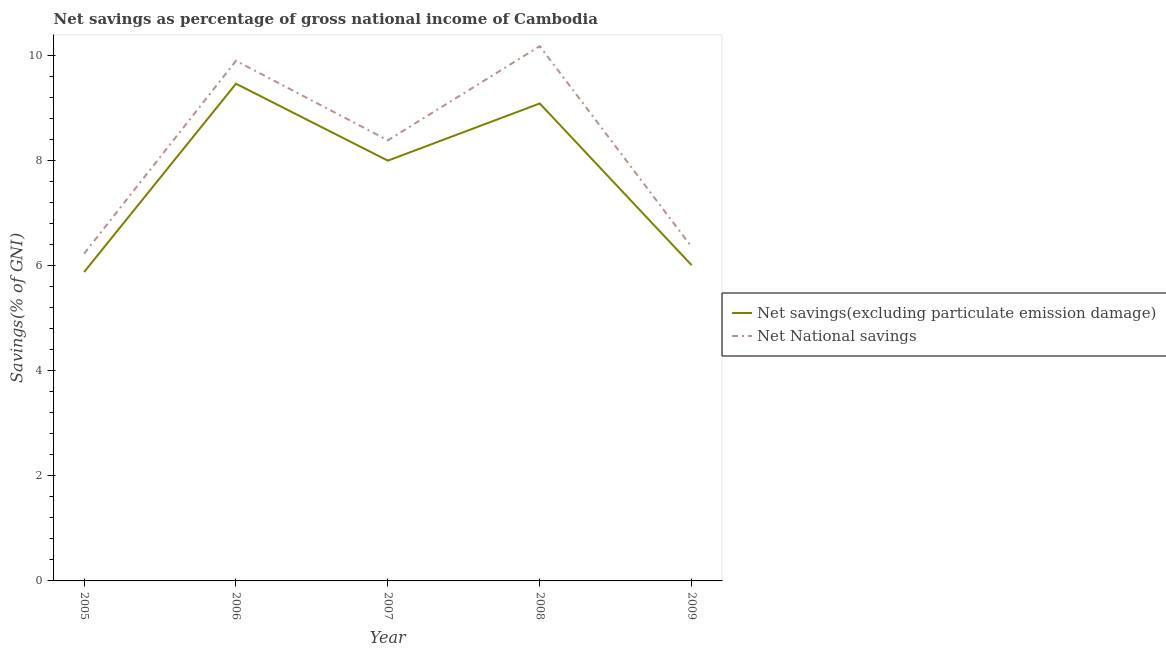How many different coloured lines are there?
Your answer should be compact. 2. What is the net national savings in 2006?
Your response must be concise. 9.9. Across all years, what is the maximum net savings(excluding particulate emission damage)?
Your answer should be very brief. 9.46. Across all years, what is the minimum net national savings?
Provide a short and direct response. 6.23. In which year was the net savings(excluding particulate emission damage) maximum?
Make the answer very short. 2006. What is the total net savings(excluding particulate emission damage) in the graph?
Ensure brevity in your answer.  38.44. What is the difference between the net savings(excluding particulate emission damage) in 2006 and that in 2009?
Your response must be concise. 3.45. What is the difference between the net savings(excluding particulate emission damage) in 2005 and the net national savings in 2006?
Ensure brevity in your answer.  -4.02. What is the average net savings(excluding particulate emission damage) per year?
Offer a very short reply. 7.69. In the year 2005, what is the difference between the net savings(excluding particulate emission damage) and net national savings?
Your response must be concise. -0.35. In how many years, is the net savings(excluding particulate emission damage) greater than 2 %?
Make the answer very short. 5. What is the ratio of the net savings(excluding particulate emission damage) in 2006 to that in 2008?
Your response must be concise. 1.04. Is the net national savings in 2006 less than that in 2007?
Your answer should be compact. No. What is the difference between the highest and the second highest net savings(excluding particulate emission damage)?
Provide a short and direct response. 0.38. What is the difference between the highest and the lowest net savings(excluding particulate emission damage)?
Keep it short and to the point. 3.58. In how many years, is the net national savings greater than the average net national savings taken over all years?
Provide a succinct answer. 3. Is the sum of the net savings(excluding particulate emission damage) in 2007 and 2008 greater than the maximum net national savings across all years?
Give a very brief answer. Yes. Does the net savings(excluding particulate emission damage) monotonically increase over the years?
Make the answer very short. No. Is the net savings(excluding particulate emission damage) strictly greater than the net national savings over the years?
Make the answer very short. No. How many years are there in the graph?
Offer a terse response. 5. Are the values on the major ticks of Y-axis written in scientific E-notation?
Ensure brevity in your answer.  No. How are the legend labels stacked?
Provide a short and direct response. Vertical. What is the title of the graph?
Offer a very short reply. Net savings as percentage of gross national income of Cambodia. What is the label or title of the Y-axis?
Give a very brief answer. Savings(% of GNI). What is the Savings(% of GNI) of Net savings(excluding particulate emission damage) in 2005?
Provide a succinct answer. 5.88. What is the Savings(% of GNI) of Net National savings in 2005?
Offer a very short reply. 6.23. What is the Savings(% of GNI) in Net savings(excluding particulate emission damage) in 2006?
Make the answer very short. 9.46. What is the Savings(% of GNI) in Net National savings in 2006?
Ensure brevity in your answer.  9.9. What is the Savings(% of GNI) of Net savings(excluding particulate emission damage) in 2007?
Give a very brief answer. 8. What is the Savings(% of GNI) in Net National savings in 2007?
Offer a very short reply. 8.39. What is the Savings(% of GNI) of Net savings(excluding particulate emission damage) in 2008?
Make the answer very short. 9.09. What is the Savings(% of GNI) in Net National savings in 2008?
Keep it short and to the point. 10.18. What is the Savings(% of GNI) in Net savings(excluding particulate emission damage) in 2009?
Make the answer very short. 6.01. What is the Savings(% of GNI) of Net National savings in 2009?
Keep it short and to the point. 6.36. Across all years, what is the maximum Savings(% of GNI) in Net savings(excluding particulate emission damage)?
Provide a succinct answer. 9.46. Across all years, what is the maximum Savings(% of GNI) in Net National savings?
Keep it short and to the point. 10.18. Across all years, what is the minimum Savings(% of GNI) of Net savings(excluding particulate emission damage)?
Your answer should be compact. 5.88. Across all years, what is the minimum Savings(% of GNI) of Net National savings?
Keep it short and to the point. 6.23. What is the total Savings(% of GNI) in Net savings(excluding particulate emission damage) in the graph?
Provide a succinct answer. 38.44. What is the total Savings(% of GNI) in Net National savings in the graph?
Your answer should be very brief. 41.05. What is the difference between the Savings(% of GNI) of Net savings(excluding particulate emission damage) in 2005 and that in 2006?
Your response must be concise. -3.58. What is the difference between the Savings(% of GNI) of Net National savings in 2005 and that in 2006?
Provide a short and direct response. -3.67. What is the difference between the Savings(% of GNI) of Net savings(excluding particulate emission damage) in 2005 and that in 2007?
Provide a short and direct response. -2.12. What is the difference between the Savings(% of GNI) of Net National savings in 2005 and that in 2007?
Your answer should be very brief. -2.16. What is the difference between the Savings(% of GNI) in Net savings(excluding particulate emission damage) in 2005 and that in 2008?
Your response must be concise. -3.21. What is the difference between the Savings(% of GNI) of Net National savings in 2005 and that in 2008?
Your answer should be very brief. -3.95. What is the difference between the Savings(% of GNI) of Net savings(excluding particulate emission damage) in 2005 and that in 2009?
Provide a succinct answer. -0.13. What is the difference between the Savings(% of GNI) in Net National savings in 2005 and that in 2009?
Offer a very short reply. -0.13. What is the difference between the Savings(% of GNI) of Net savings(excluding particulate emission damage) in 2006 and that in 2007?
Offer a terse response. 1.46. What is the difference between the Savings(% of GNI) in Net National savings in 2006 and that in 2007?
Your answer should be compact. 1.51. What is the difference between the Savings(% of GNI) in Net savings(excluding particulate emission damage) in 2006 and that in 2008?
Offer a terse response. 0.38. What is the difference between the Savings(% of GNI) in Net National savings in 2006 and that in 2008?
Make the answer very short. -0.28. What is the difference between the Savings(% of GNI) of Net savings(excluding particulate emission damage) in 2006 and that in 2009?
Your response must be concise. 3.45. What is the difference between the Savings(% of GNI) in Net National savings in 2006 and that in 2009?
Keep it short and to the point. 3.54. What is the difference between the Savings(% of GNI) of Net savings(excluding particulate emission damage) in 2007 and that in 2008?
Your answer should be very brief. -1.09. What is the difference between the Savings(% of GNI) in Net National savings in 2007 and that in 2008?
Make the answer very short. -1.79. What is the difference between the Savings(% of GNI) of Net savings(excluding particulate emission damage) in 2007 and that in 2009?
Make the answer very short. 1.99. What is the difference between the Savings(% of GNI) of Net National savings in 2007 and that in 2009?
Your response must be concise. 2.03. What is the difference between the Savings(% of GNI) of Net savings(excluding particulate emission damage) in 2008 and that in 2009?
Ensure brevity in your answer.  3.08. What is the difference between the Savings(% of GNI) of Net National savings in 2008 and that in 2009?
Your response must be concise. 3.82. What is the difference between the Savings(% of GNI) of Net savings(excluding particulate emission damage) in 2005 and the Savings(% of GNI) of Net National savings in 2006?
Keep it short and to the point. -4.02. What is the difference between the Savings(% of GNI) in Net savings(excluding particulate emission damage) in 2005 and the Savings(% of GNI) in Net National savings in 2007?
Offer a terse response. -2.51. What is the difference between the Savings(% of GNI) in Net savings(excluding particulate emission damage) in 2005 and the Savings(% of GNI) in Net National savings in 2008?
Your answer should be very brief. -4.3. What is the difference between the Savings(% of GNI) in Net savings(excluding particulate emission damage) in 2005 and the Savings(% of GNI) in Net National savings in 2009?
Your response must be concise. -0.48. What is the difference between the Savings(% of GNI) of Net savings(excluding particulate emission damage) in 2006 and the Savings(% of GNI) of Net National savings in 2007?
Make the answer very short. 1.08. What is the difference between the Savings(% of GNI) of Net savings(excluding particulate emission damage) in 2006 and the Savings(% of GNI) of Net National savings in 2008?
Your answer should be very brief. -0.72. What is the difference between the Savings(% of GNI) of Net savings(excluding particulate emission damage) in 2006 and the Savings(% of GNI) of Net National savings in 2009?
Make the answer very short. 3.11. What is the difference between the Savings(% of GNI) in Net savings(excluding particulate emission damage) in 2007 and the Savings(% of GNI) in Net National savings in 2008?
Ensure brevity in your answer.  -2.18. What is the difference between the Savings(% of GNI) in Net savings(excluding particulate emission damage) in 2007 and the Savings(% of GNI) in Net National savings in 2009?
Offer a terse response. 1.64. What is the difference between the Savings(% of GNI) of Net savings(excluding particulate emission damage) in 2008 and the Savings(% of GNI) of Net National savings in 2009?
Offer a very short reply. 2.73. What is the average Savings(% of GNI) in Net savings(excluding particulate emission damage) per year?
Offer a very short reply. 7.69. What is the average Savings(% of GNI) in Net National savings per year?
Your response must be concise. 8.21. In the year 2005, what is the difference between the Savings(% of GNI) of Net savings(excluding particulate emission damage) and Savings(% of GNI) of Net National savings?
Ensure brevity in your answer.  -0.35. In the year 2006, what is the difference between the Savings(% of GNI) in Net savings(excluding particulate emission damage) and Savings(% of GNI) in Net National savings?
Offer a terse response. -0.44. In the year 2007, what is the difference between the Savings(% of GNI) in Net savings(excluding particulate emission damage) and Savings(% of GNI) in Net National savings?
Offer a very short reply. -0.39. In the year 2008, what is the difference between the Savings(% of GNI) of Net savings(excluding particulate emission damage) and Savings(% of GNI) of Net National savings?
Keep it short and to the point. -1.09. In the year 2009, what is the difference between the Savings(% of GNI) of Net savings(excluding particulate emission damage) and Savings(% of GNI) of Net National savings?
Make the answer very short. -0.35. What is the ratio of the Savings(% of GNI) of Net savings(excluding particulate emission damage) in 2005 to that in 2006?
Keep it short and to the point. 0.62. What is the ratio of the Savings(% of GNI) in Net National savings in 2005 to that in 2006?
Offer a very short reply. 0.63. What is the ratio of the Savings(% of GNI) of Net savings(excluding particulate emission damage) in 2005 to that in 2007?
Provide a short and direct response. 0.73. What is the ratio of the Savings(% of GNI) of Net National savings in 2005 to that in 2007?
Ensure brevity in your answer.  0.74. What is the ratio of the Savings(% of GNI) of Net savings(excluding particulate emission damage) in 2005 to that in 2008?
Keep it short and to the point. 0.65. What is the ratio of the Savings(% of GNI) of Net National savings in 2005 to that in 2008?
Make the answer very short. 0.61. What is the ratio of the Savings(% of GNI) of Net savings(excluding particulate emission damage) in 2005 to that in 2009?
Ensure brevity in your answer.  0.98. What is the ratio of the Savings(% of GNI) of Net National savings in 2005 to that in 2009?
Ensure brevity in your answer.  0.98. What is the ratio of the Savings(% of GNI) in Net savings(excluding particulate emission damage) in 2006 to that in 2007?
Your answer should be compact. 1.18. What is the ratio of the Savings(% of GNI) of Net National savings in 2006 to that in 2007?
Give a very brief answer. 1.18. What is the ratio of the Savings(% of GNI) of Net savings(excluding particulate emission damage) in 2006 to that in 2008?
Offer a terse response. 1.04. What is the ratio of the Savings(% of GNI) in Net National savings in 2006 to that in 2008?
Provide a succinct answer. 0.97. What is the ratio of the Savings(% of GNI) of Net savings(excluding particulate emission damage) in 2006 to that in 2009?
Your response must be concise. 1.57. What is the ratio of the Savings(% of GNI) of Net National savings in 2006 to that in 2009?
Provide a succinct answer. 1.56. What is the ratio of the Savings(% of GNI) of Net savings(excluding particulate emission damage) in 2007 to that in 2008?
Your response must be concise. 0.88. What is the ratio of the Savings(% of GNI) in Net National savings in 2007 to that in 2008?
Your answer should be compact. 0.82. What is the ratio of the Savings(% of GNI) in Net savings(excluding particulate emission damage) in 2007 to that in 2009?
Provide a short and direct response. 1.33. What is the ratio of the Savings(% of GNI) in Net National savings in 2007 to that in 2009?
Your answer should be very brief. 1.32. What is the ratio of the Savings(% of GNI) of Net savings(excluding particulate emission damage) in 2008 to that in 2009?
Provide a short and direct response. 1.51. What is the ratio of the Savings(% of GNI) of Net National savings in 2008 to that in 2009?
Ensure brevity in your answer.  1.6. What is the difference between the highest and the second highest Savings(% of GNI) of Net savings(excluding particulate emission damage)?
Give a very brief answer. 0.38. What is the difference between the highest and the second highest Savings(% of GNI) in Net National savings?
Provide a short and direct response. 0.28. What is the difference between the highest and the lowest Savings(% of GNI) in Net savings(excluding particulate emission damage)?
Give a very brief answer. 3.58. What is the difference between the highest and the lowest Savings(% of GNI) in Net National savings?
Offer a very short reply. 3.95. 